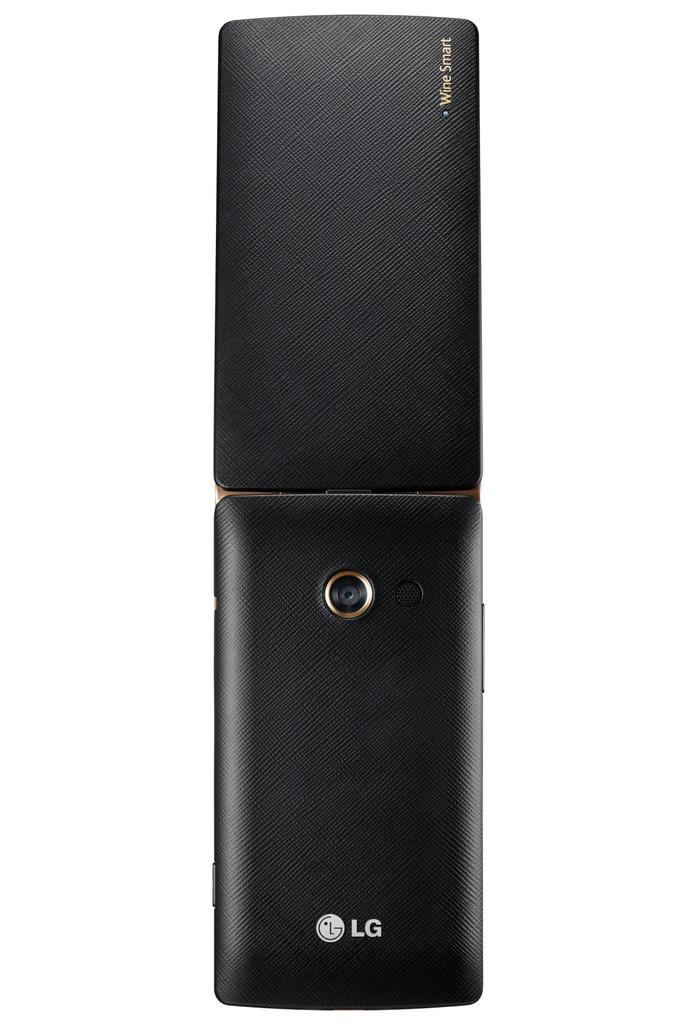<image>
Provide a brief description of the given image. a phone that has LG written at the bottom of it 